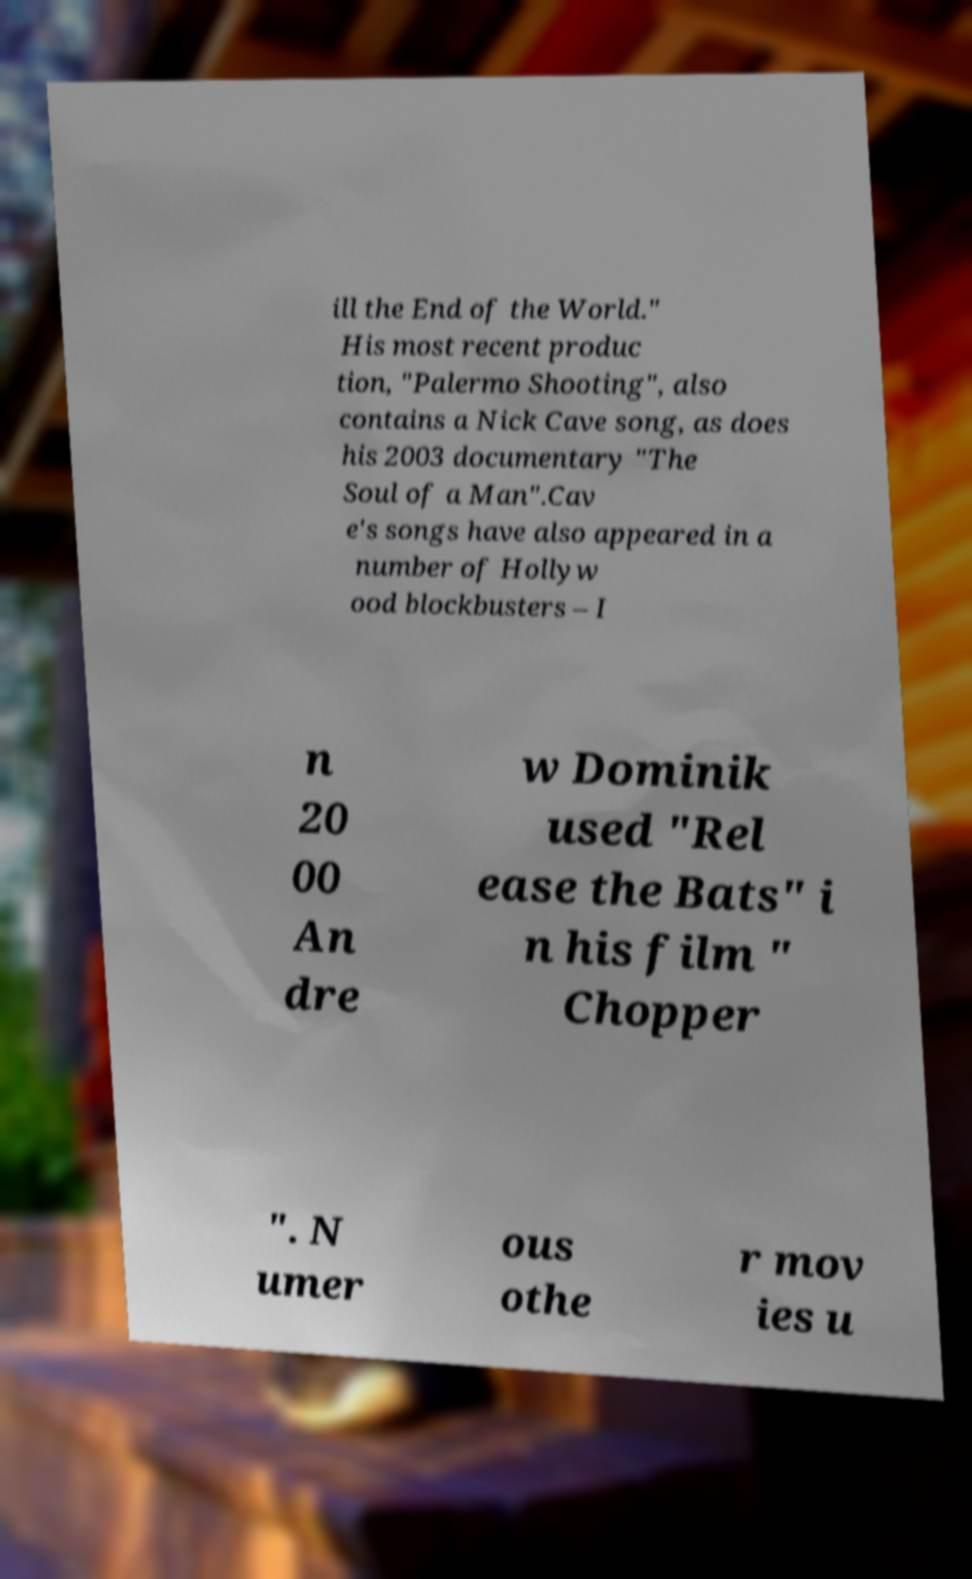There's text embedded in this image that I need extracted. Can you transcribe it verbatim? ill the End of the World." His most recent produc tion, "Palermo Shooting", also contains a Nick Cave song, as does his 2003 documentary "The Soul of a Man".Cav e's songs have also appeared in a number of Hollyw ood blockbusters – I n 20 00 An dre w Dominik used "Rel ease the Bats" i n his film " Chopper ". N umer ous othe r mov ies u 